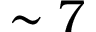<formula> <loc_0><loc_0><loc_500><loc_500>\sim 7</formula> 